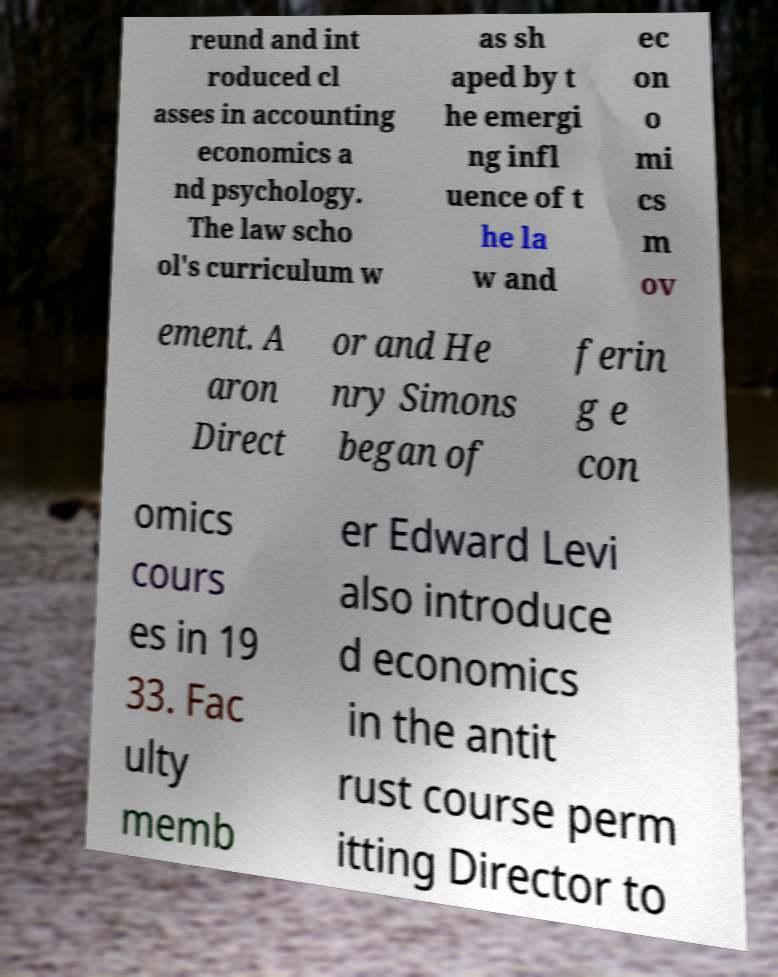What messages or text are displayed in this image? I need them in a readable, typed format. reund and int roduced cl asses in accounting economics a nd psychology. The law scho ol's curriculum w as sh aped by t he emergi ng infl uence of t he la w and ec on o mi cs m ov ement. A aron Direct or and He nry Simons began of ferin g e con omics cours es in 19 33. Fac ulty memb er Edward Levi also introduce d economics in the antit rust course perm itting Director to 